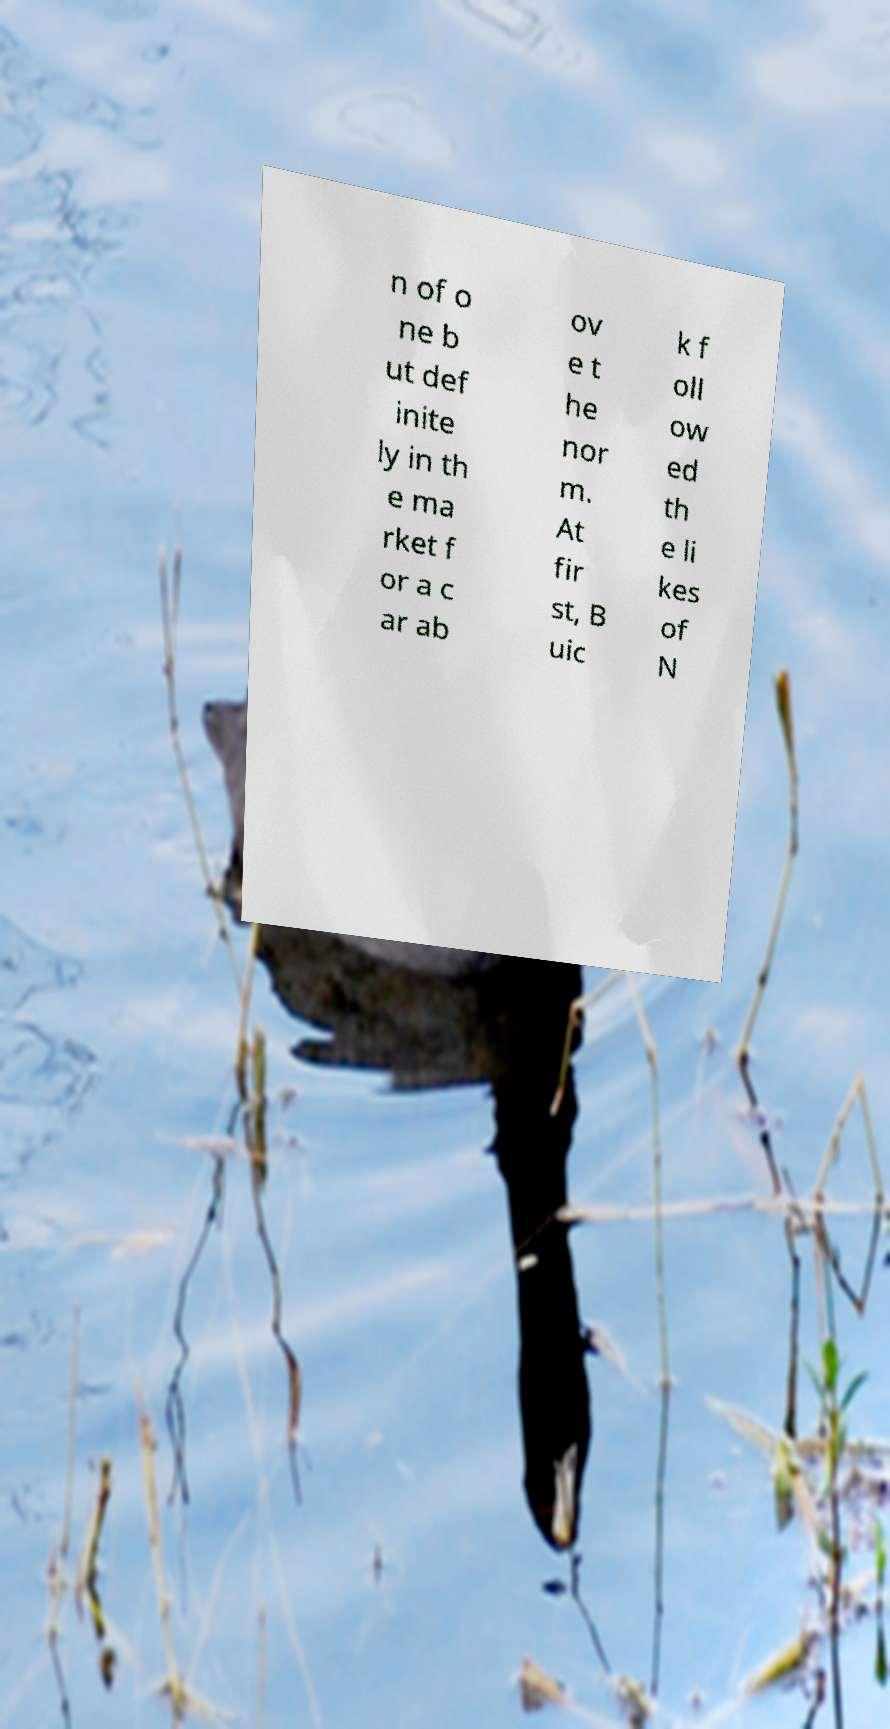Could you extract and type out the text from this image? n of o ne b ut def inite ly in th e ma rket f or a c ar ab ov e t he nor m. At fir st, B uic k f oll ow ed th e li kes of N 